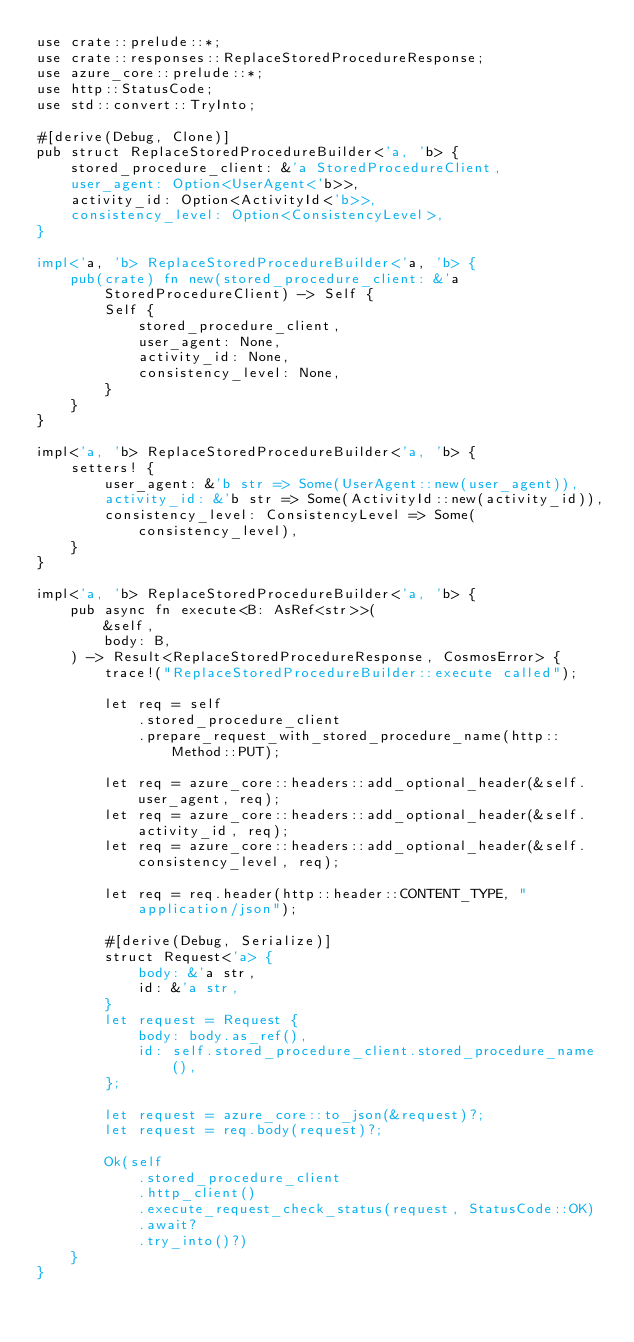Convert code to text. <code><loc_0><loc_0><loc_500><loc_500><_Rust_>use crate::prelude::*;
use crate::responses::ReplaceStoredProcedureResponse;
use azure_core::prelude::*;
use http::StatusCode;
use std::convert::TryInto;

#[derive(Debug, Clone)]
pub struct ReplaceStoredProcedureBuilder<'a, 'b> {
    stored_procedure_client: &'a StoredProcedureClient,
    user_agent: Option<UserAgent<'b>>,
    activity_id: Option<ActivityId<'b>>,
    consistency_level: Option<ConsistencyLevel>,
}

impl<'a, 'b> ReplaceStoredProcedureBuilder<'a, 'b> {
    pub(crate) fn new(stored_procedure_client: &'a StoredProcedureClient) -> Self {
        Self {
            stored_procedure_client,
            user_agent: None,
            activity_id: None,
            consistency_level: None,
        }
    }
}

impl<'a, 'b> ReplaceStoredProcedureBuilder<'a, 'b> {
    setters! {
        user_agent: &'b str => Some(UserAgent::new(user_agent)),
        activity_id: &'b str => Some(ActivityId::new(activity_id)),
        consistency_level: ConsistencyLevel => Some(consistency_level),
    }
}

impl<'a, 'b> ReplaceStoredProcedureBuilder<'a, 'b> {
    pub async fn execute<B: AsRef<str>>(
        &self,
        body: B,
    ) -> Result<ReplaceStoredProcedureResponse, CosmosError> {
        trace!("ReplaceStoredProcedureBuilder::execute called");

        let req = self
            .stored_procedure_client
            .prepare_request_with_stored_procedure_name(http::Method::PUT);

        let req = azure_core::headers::add_optional_header(&self.user_agent, req);
        let req = azure_core::headers::add_optional_header(&self.activity_id, req);
        let req = azure_core::headers::add_optional_header(&self.consistency_level, req);

        let req = req.header(http::header::CONTENT_TYPE, "application/json");

        #[derive(Debug, Serialize)]
        struct Request<'a> {
            body: &'a str,
            id: &'a str,
        }
        let request = Request {
            body: body.as_ref(),
            id: self.stored_procedure_client.stored_procedure_name(),
        };

        let request = azure_core::to_json(&request)?;
        let request = req.body(request)?;

        Ok(self
            .stored_procedure_client
            .http_client()
            .execute_request_check_status(request, StatusCode::OK)
            .await?
            .try_into()?)
    }
}
</code> 